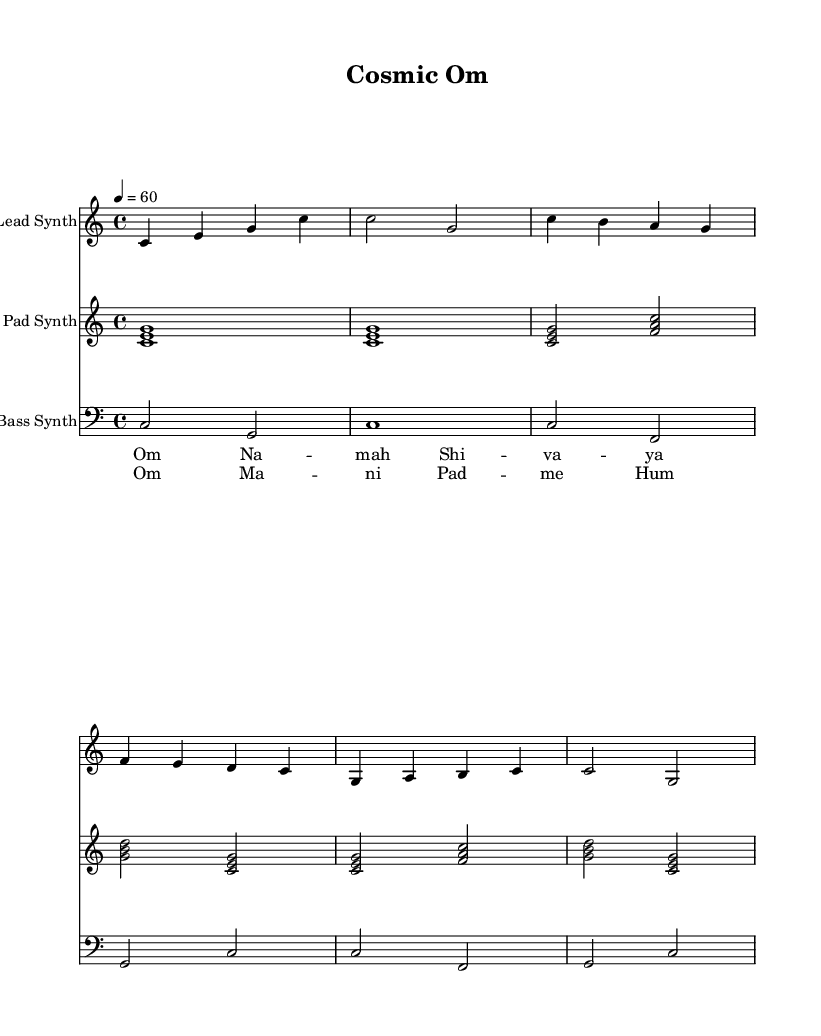What is the key signature of this music? The key signature is C major, which is indicated at the beginning of the piece. There are no sharps or flats present in this key signature.
Answer: C major What is the time signature of this music? The time signature is 4/4, which is displayed at the beginning of the score. It indicates that there are four beats per measure and the quarter note gets one beat.
Answer: 4/4 What is the tempo marking for this piece? The tempo marking indicates that the piece should be played at a speed of 60 beats per minute (BPM), which is shown in the score as "4 = 60."
Answer: 60 How many distinct musical sections are present in the score? The score has three distinct sections: Intro, Verse, and Chorus. Each section is defined by different melodies and harmonies.
Answer: Three What type of synthesizer is used for the bass line? The bass line is performed by a bass synthesizer, which can be inferred from the clef indicated as bass in the corresponding staff.
Answer: Bass Synth Which mantra is sung during the chorus section? The lyrics for the chorus section are "Om Ma ni Pad me Hum," which can be identified from the lyrics associated with the chorus in the score.
Answer: Om Ma ni Pad me Hum How does the pad synth contribute to the overall texture of the piece? The pad synth provides harmonic support through the use of sustained chords, which enriches the overall sound and adds atmospheric texture to the music.
Answer: Harmonic support 